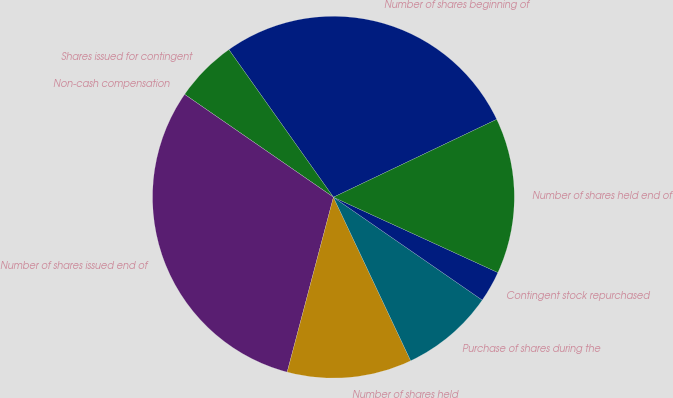<chart> <loc_0><loc_0><loc_500><loc_500><pie_chart><fcel>Number of shares beginning of<fcel>Shares issued for contingent<fcel>Non-cash compensation<fcel>Number of shares issued end of<fcel>Number of shares held<fcel>Purchase of shares during the<fcel>Contingent stock repurchased<fcel>Number of shares held end of<nl><fcel>27.73%<fcel>5.57%<fcel>0.0%<fcel>30.51%<fcel>11.14%<fcel>8.35%<fcel>2.79%<fcel>13.92%<nl></chart> 